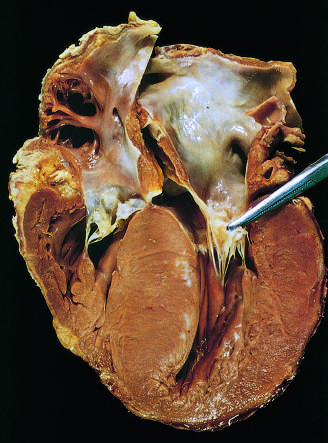what bulges into the left ventricular outflow tract, giving rise to a banana-shaped ventricular lumen?
Answer the question using a single word or phrase. The septal muscle 